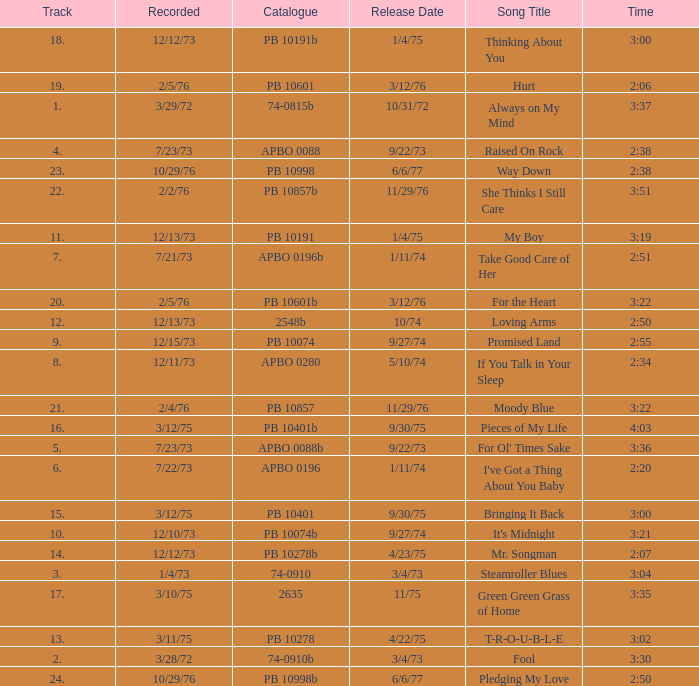Name the catalogue that has tracks less than 13 and the release date of 10/31/72 74-0815b. 